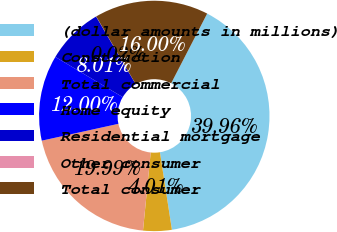<chart> <loc_0><loc_0><loc_500><loc_500><pie_chart><fcel>(dollar amounts in millions)<fcel>Construction<fcel>Total commercial<fcel>Home equity<fcel>Residential mortgage<fcel>Other consumer<fcel>Total consumer<nl><fcel>39.96%<fcel>4.01%<fcel>19.99%<fcel>12.0%<fcel>8.01%<fcel>0.02%<fcel>16.0%<nl></chart> 